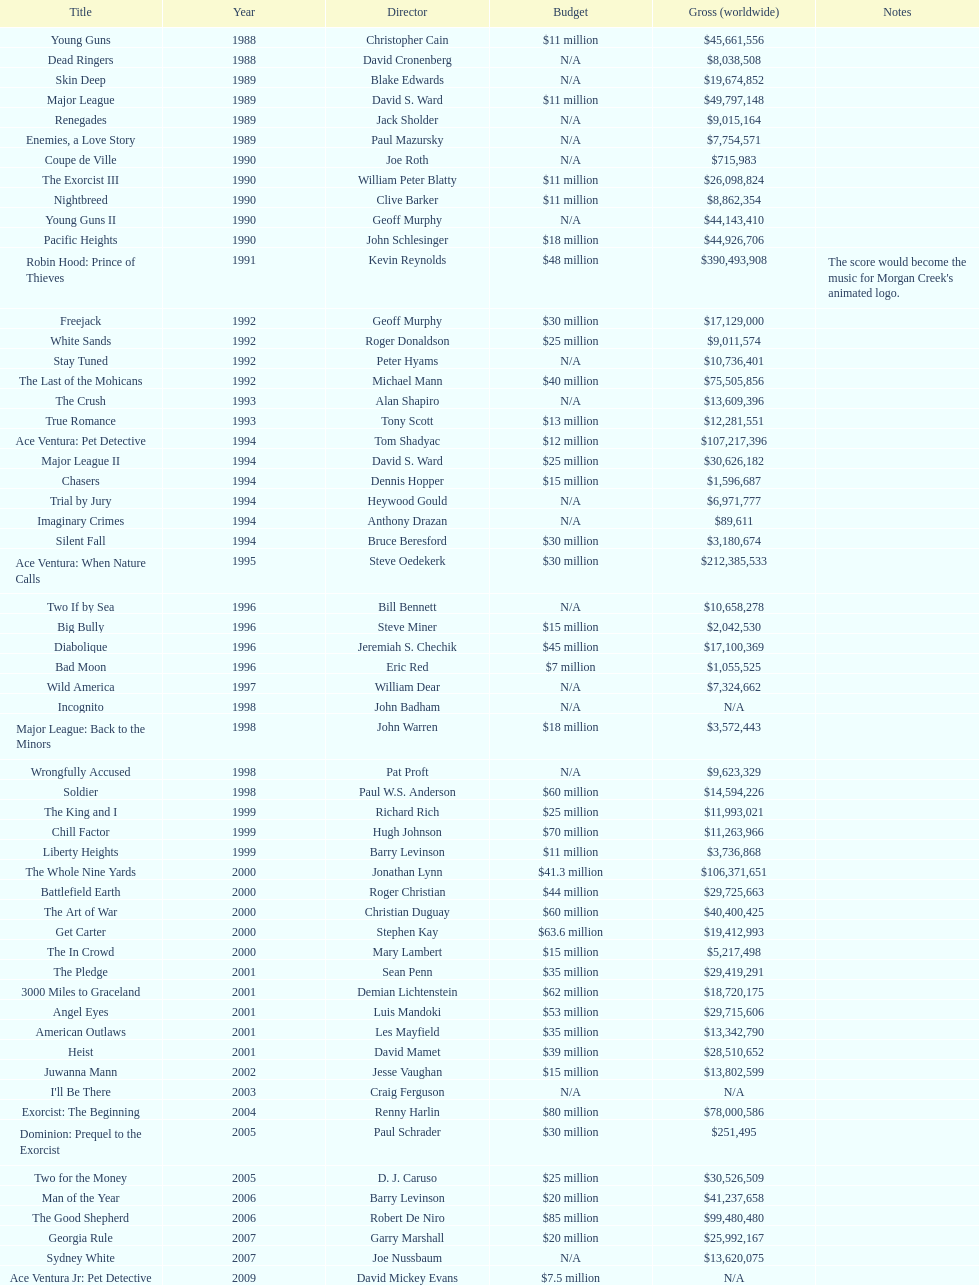Which single film had a budget of 48 million dollars? Robin Hood: Prince of Thieves. 